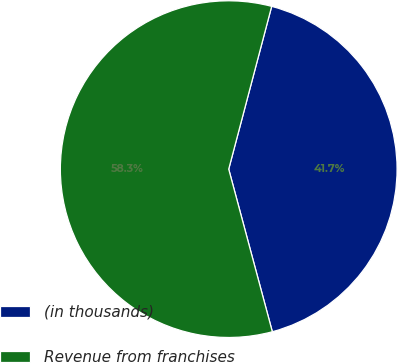Convert chart. <chart><loc_0><loc_0><loc_500><loc_500><pie_chart><fcel>(in thousands)<fcel>Revenue from franchises<nl><fcel>41.72%<fcel>58.28%<nl></chart> 